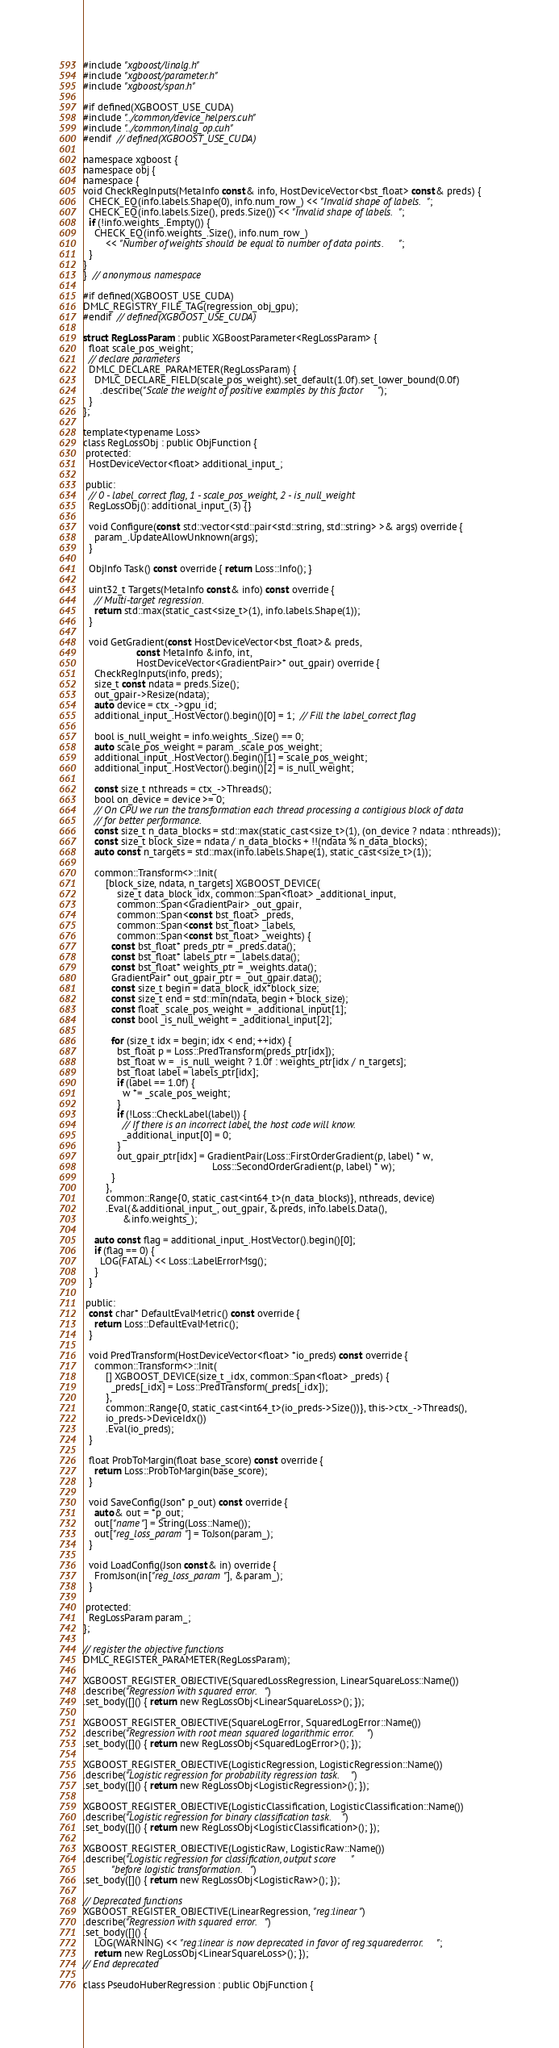<code> <loc_0><loc_0><loc_500><loc_500><_Cuda_>#include "xgboost/linalg.h"
#include "xgboost/parameter.h"
#include "xgboost/span.h"

#if defined(XGBOOST_USE_CUDA)
#include "../common/device_helpers.cuh"
#include "../common/linalg_op.cuh"
#endif  // defined(XGBOOST_USE_CUDA)

namespace xgboost {
namespace obj {
namespace {
void CheckRegInputs(MetaInfo const& info, HostDeviceVector<bst_float> const& preds) {
  CHECK_EQ(info.labels.Shape(0), info.num_row_) << "Invalid shape of labels.";
  CHECK_EQ(info.labels.Size(), preds.Size()) << "Invalid shape of labels.";
  if (!info.weights_.Empty()) {
    CHECK_EQ(info.weights_.Size(), info.num_row_)
        << "Number of weights should be equal to number of data points.";
  }
}
}  // anonymous namespace

#if defined(XGBOOST_USE_CUDA)
DMLC_REGISTRY_FILE_TAG(regression_obj_gpu);
#endif  // defined(XGBOOST_USE_CUDA)

struct RegLossParam : public XGBoostParameter<RegLossParam> {
  float scale_pos_weight;
  // declare parameters
  DMLC_DECLARE_PARAMETER(RegLossParam) {
    DMLC_DECLARE_FIELD(scale_pos_weight).set_default(1.0f).set_lower_bound(0.0f)
      .describe("Scale the weight of positive examples by this factor");
  }
};

template<typename Loss>
class RegLossObj : public ObjFunction {
 protected:
  HostDeviceVector<float> additional_input_;

 public:
  // 0 - label_correct flag, 1 - scale_pos_weight, 2 - is_null_weight
  RegLossObj(): additional_input_(3) {}

  void Configure(const std::vector<std::pair<std::string, std::string> >& args) override {
    param_.UpdateAllowUnknown(args);
  }

  ObjInfo Task() const override { return Loss::Info(); }

  uint32_t Targets(MetaInfo const& info) const override {
    // Multi-target regression.
    return std::max(static_cast<size_t>(1), info.labels.Shape(1));
  }

  void GetGradient(const HostDeviceVector<bst_float>& preds,
                   const MetaInfo &info, int,
                   HostDeviceVector<GradientPair>* out_gpair) override {
    CheckRegInputs(info, preds);
    size_t const ndata = preds.Size();
    out_gpair->Resize(ndata);
    auto device = ctx_->gpu_id;
    additional_input_.HostVector().begin()[0] = 1;  // Fill the label_correct flag

    bool is_null_weight = info.weights_.Size() == 0;
    auto scale_pos_weight = param_.scale_pos_weight;
    additional_input_.HostVector().begin()[1] = scale_pos_weight;
    additional_input_.HostVector().begin()[2] = is_null_weight;

    const size_t nthreads = ctx_->Threads();
    bool on_device = device >= 0;
    // On CPU we run the transformation each thread processing a contigious block of data
    // for better performance.
    const size_t n_data_blocks = std::max(static_cast<size_t>(1), (on_device ? ndata : nthreads));
    const size_t block_size = ndata / n_data_blocks + !!(ndata % n_data_blocks);
    auto const n_targets = std::max(info.labels.Shape(1), static_cast<size_t>(1));

    common::Transform<>::Init(
        [block_size, ndata, n_targets] XGBOOST_DEVICE(
            size_t data_block_idx, common::Span<float> _additional_input,
            common::Span<GradientPair> _out_gpair,
            common::Span<const bst_float> _preds,
            common::Span<const bst_float> _labels,
            common::Span<const bst_float> _weights) {
          const bst_float* preds_ptr = _preds.data();
          const bst_float* labels_ptr = _labels.data();
          const bst_float* weights_ptr = _weights.data();
          GradientPair* out_gpair_ptr = _out_gpair.data();
          const size_t begin = data_block_idx*block_size;
          const size_t end = std::min(ndata, begin + block_size);
          const float _scale_pos_weight = _additional_input[1];
          const bool _is_null_weight = _additional_input[2];

          for (size_t idx = begin; idx < end; ++idx) {
            bst_float p = Loss::PredTransform(preds_ptr[idx]);
            bst_float w = _is_null_weight ? 1.0f : weights_ptr[idx / n_targets];
            bst_float label = labels_ptr[idx];
            if (label == 1.0f) {
              w *= _scale_pos_weight;
            }
            if (!Loss::CheckLabel(label)) {
              // If there is an incorrect label, the host code will know.
              _additional_input[0] = 0;
            }
            out_gpair_ptr[idx] = GradientPair(Loss::FirstOrderGradient(p, label) * w,
                                              Loss::SecondOrderGradient(p, label) * w);
          }
        },
        common::Range{0, static_cast<int64_t>(n_data_blocks)}, nthreads, device)
        .Eval(&additional_input_, out_gpair, &preds, info.labels.Data(),
              &info.weights_);

    auto const flag = additional_input_.HostVector().begin()[0];
    if (flag == 0) {
      LOG(FATAL) << Loss::LabelErrorMsg();
    }
  }

 public:
  const char* DefaultEvalMetric() const override {
    return Loss::DefaultEvalMetric();
  }

  void PredTransform(HostDeviceVector<float> *io_preds) const override {
    common::Transform<>::Init(
        [] XGBOOST_DEVICE(size_t _idx, common::Span<float> _preds) {
          _preds[_idx] = Loss::PredTransform(_preds[_idx]);
        },
        common::Range{0, static_cast<int64_t>(io_preds->Size())}, this->ctx_->Threads(),
        io_preds->DeviceIdx())
        .Eval(io_preds);
  }

  float ProbToMargin(float base_score) const override {
    return Loss::ProbToMargin(base_score);
  }

  void SaveConfig(Json* p_out) const override {
    auto& out = *p_out;
    out["name"] = String(Loss::Name());
    out["reg_loss_param"] = ToJson(param_);
  }

  void LoadConfig(Json const& in) override {
    FromJson(in["reg_loss_param"], &param_);
  }

 protected:
  RegLossParam param_;
};

// register the objective functions
DMLC_REGISTER_PARAMETER(RegLossParam);

XGBOOST_REGISTER_OBJECTIVE(SquaredLossRegression, LinearSquareLoss::Name())
.describe("Regression with squared error.")
.set_body([]() { return new RegLossObj<LinearSquareLoss>(); });

XGBOOST_REGISTER_OBJECTIVE(SquareLogError, SquaredLogError::Name())
.describe("Regression with root mean squared logarithmic error.")
.set_body([]() { return new RegLossObj<SquaredLogError>(); });

XGBOOST_REGISTER_OBJECTIVE(LogisticRegression, LogisticRegression::Name())
.describe("Logistic regression for probability regression task.")
.set_body([]() { return new RegLossObj<LogisticRegression>(); });

XGBOOST_REGISTER_OBJECTIVE(LogisticClassification, LogisticClassification::Name())
.describe("Logistic regression for binary classification task.")
.set_body([]() { return new RegLossObj<LogisticClassification>(); });

XGBOOST_REGISTER_OBJECTIVE(LogisticRaw, LogisticRaw::Name())
.describe("Logistic regression for classification, output score "
          "before logistic transformation.")
.set_body([]() { return new RegLossObj<LogisticRaw>(); });

// Deprecated functions
XGBOOST_REGISTER_OBJECTIVE(LinearRegression, "reg:linear")
.describe("Regression with squared error.")
.set_body([]() {
    LOG(WARNING) << "reg:linear is now deprecated in favor of reg:squarederror.";
    return new RegLossObj<LinearSquareLoss>(); });
// End deprecated

class PseudoHuberRegression : public ObjFunction {</code> 